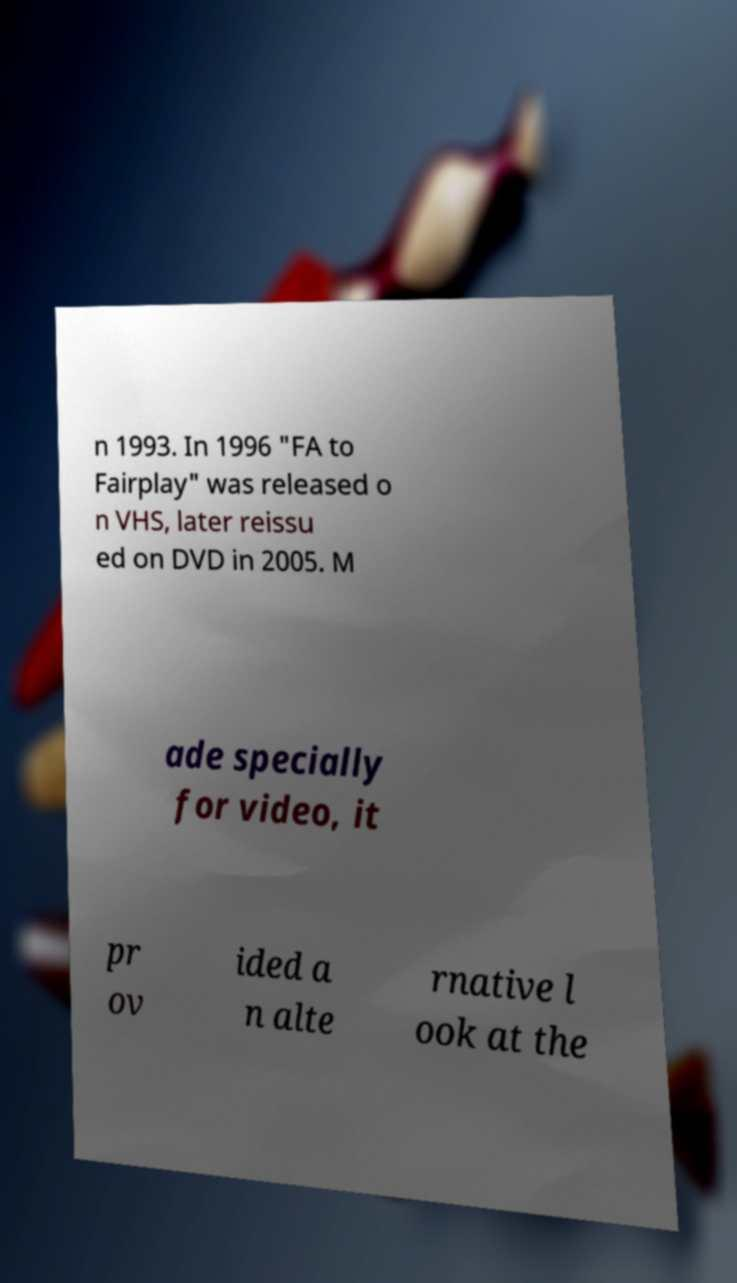What messages or text are displayed in this image? I need them in a readable, typed format. n 1993. In 1996 "FA to Fairplay" was released o n VHS, later reissu ed on DVD in 2005. M ade specially for video, it pr ov ided a n alte rnative l ook at the 